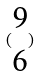<formula> <loc_0><loc_0><loc_500><loc_500>( \begin{matrix} 9 \\ 6 \end{matrix} )</formula> 